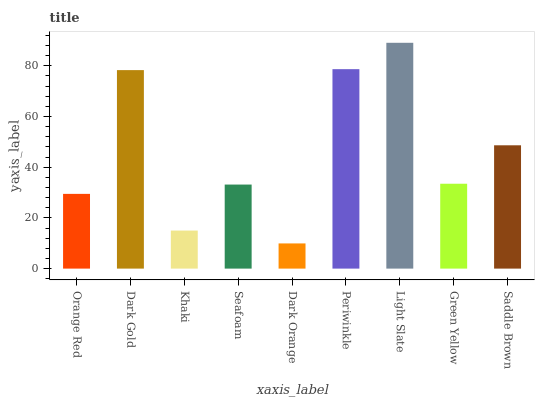Is Dark Orange the minimum?
Answer yes or no. Yes. Is Light Slate the maximum?
Answer yes or no. Yes. Is Dark Gold the minimum?
Answer yes or no. No. Is Dark Gold the maximum?
Answer yes or no. No. Is Dark Gold greater than Orange Red?
Answer yes or no. Yes. Is Orange Red less than Dark Gold?
Answer yes or no. Yes. Is Orange Red greater than Dark Gold?
Answer yes or no. No. Is Dark Gold less than Orange Red?
Answer yes or no. No. Is Green Yellow the high median?
Answer yes or no. Yes. Is Green Yellow the low median?
Answer yes or no. Yes. Is Dark Gold the high median?
Answer yes or no. No. Is Light Slate the low median?
Answer yes or no. No. 